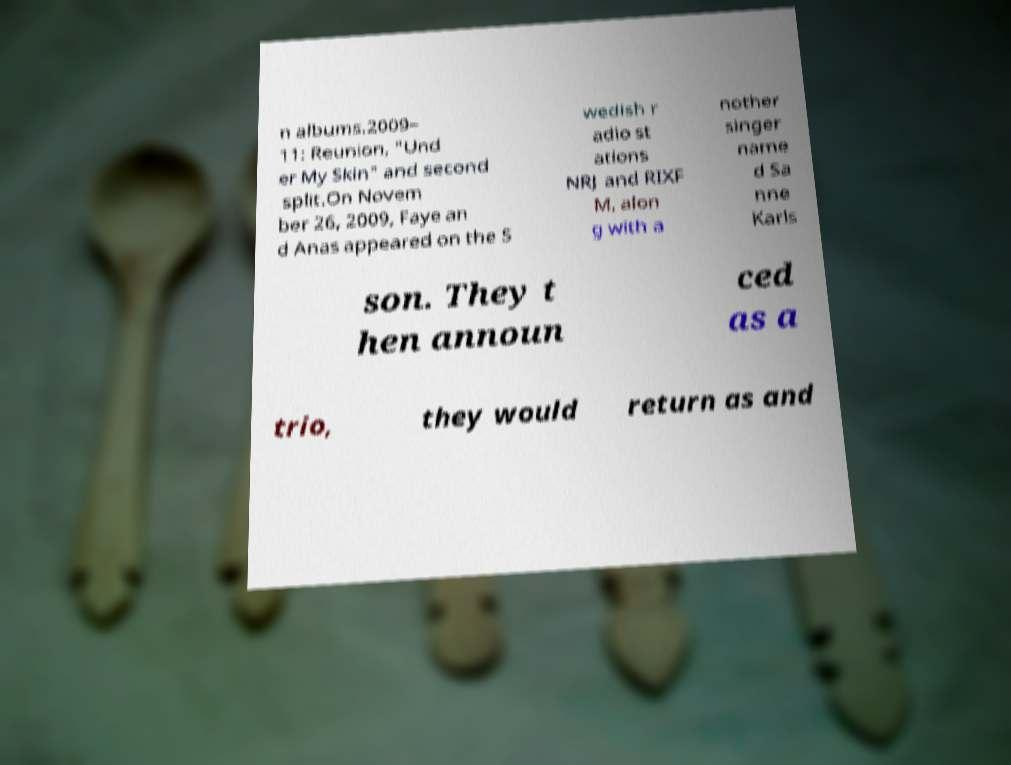Can you read and provide the text displayed in the image?This photo seems to have some interesting text. Can you extract and type it out for me? n albums.2009– 11: Reunion, "Und er My Skin" and second split.On Novem ber 26, 2009, Faye an d Anas appeared on the S wedish r adio st ations NRJ and RIXF M, alon g with a nother singer name d Sa nne Karls son. They t hen announ ced as a trio, they would return as and 